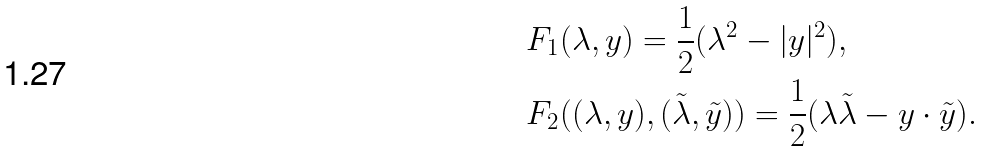<formula> <loc_0><loc_0><loc_500><loc_500>& F _ { 1 } ( \lambda , y ) = \frac { 1 } { 2 } ( \lambda ^ { 2 } - | y | ^ { 2 } ) , \\ & F _ { 2 } ( ( \lambda , y ) , ( \tilde { \lambda } , \tilde { y } ) ) = \frac { 1 } { 2 } ( \lambda \tilde { \lambda } - y \cdot \tilde { y } ) .</formula> 